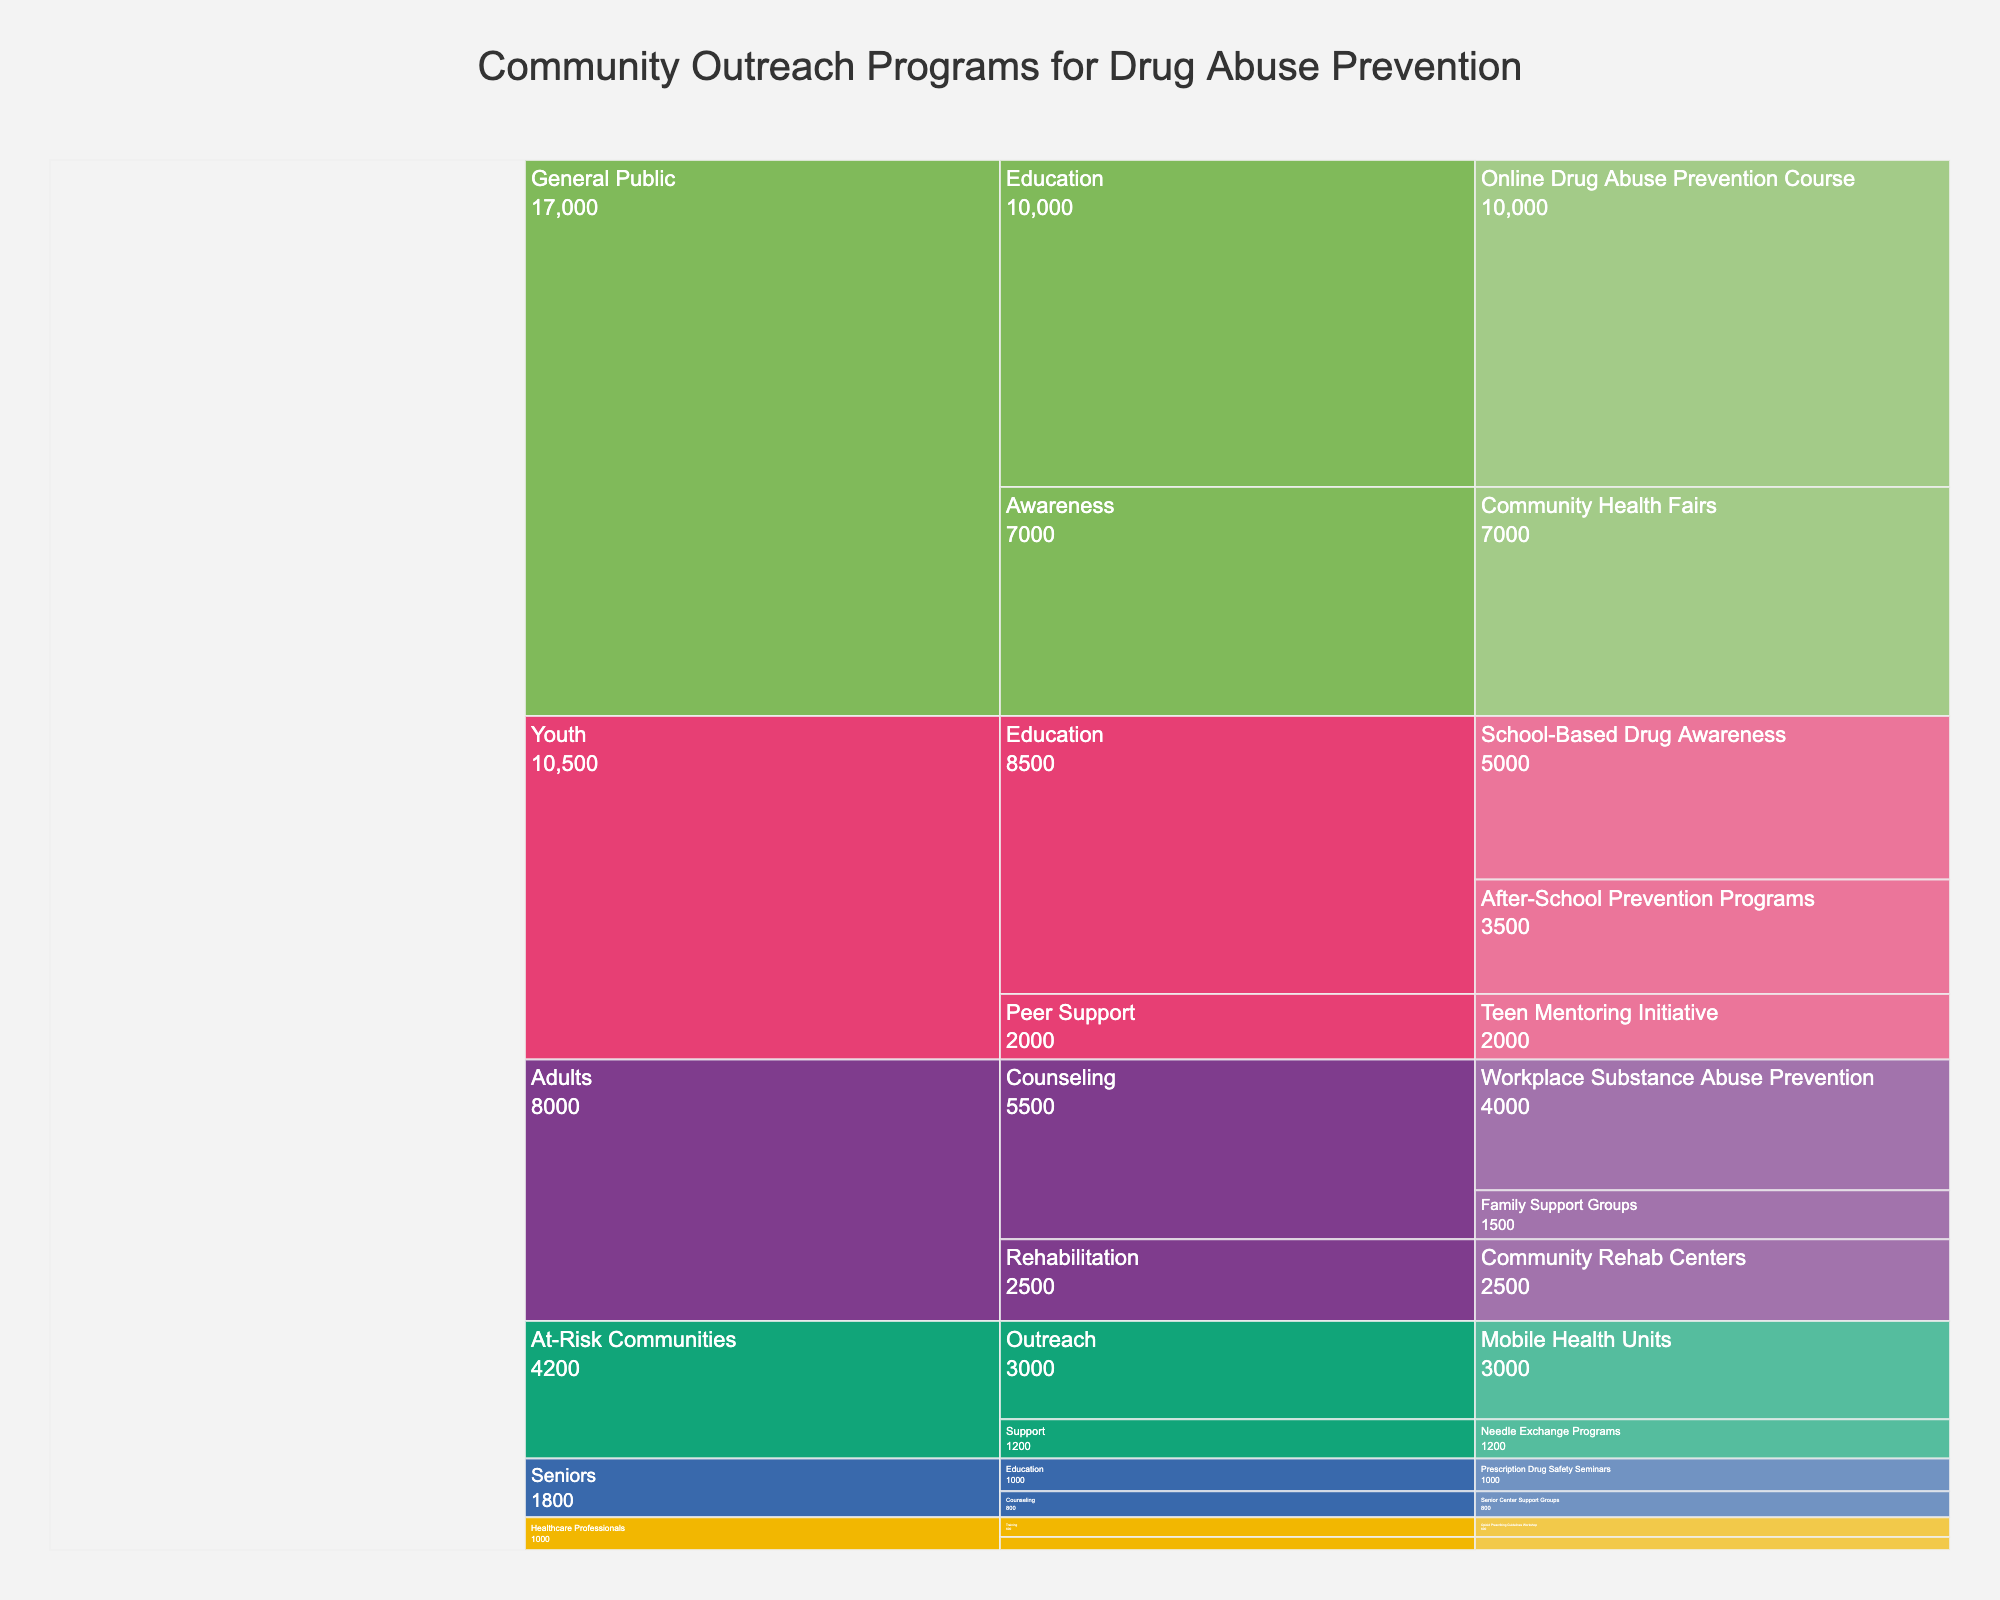What is the total number of participants in 'School-Based Drug Awareness' and 'After-School Prevention Programs'? To find the total number of participants, sum the participants in 'School-Based Drug Awareness' (5000) and 'After-School Prevention Programs' (3500). Therefore, the total is 5000 + 3500.
Answer: 8500 Which program has the highest number of participants? To determine this, look at all the programs and their participant numbers. The 'Online Drug Abuse Prevention Course' has the highest number of participants with 10,000.
Answer: Online Drug Abuse Prevention Course How many participants are involved in Education interventions for the Youth target audience? Sum the participants in 'School-Based Drug Awareness' (5000) and 'After-School Prevention Programs' (3500). Therefore, the total is 5000 + 3500.
Answer: 8500 Among the intervention methods for Adults, which one has the fewest participants? Compare the number of participants for each intervention method for Adults: Counseling (5500), Rehabilitation (2500). The fewest number of participants is for Rehabilitation with 2500 participants.
Answer: Rehabilitation What is the total number of participants for programs targeted at Healthcare Professionals? Sum the participants in 'Opioid Prescribing Guidelines Workshop' (600) and 'Substance Abuse Screening Certification' (400). Therefore, the total is 600 + 400.
Answer: 1000 Which target audience has the highest number of participants across all programs? By summing the participants in programs for each target audience and comparing, 'General Public' has the highest number of participants: 'Community Health Fairs' (7000) + 'Online Drug Abuse Prevention Course' (10000) = 17000.
Answer: General Public Which intervention method has the most participants for At-Risk Communities? Compare the number of participants for 'Mobile Health Units' (3000) and 'Needle Exchange Programs' (1200). The most participants are in 'Mobile Health Units' with 3000.
Answer: Mobile Health Units Between 'Teen Mentoring Initiative' and 'Family Support Groups', which has more participants? Compare the number of participants in 'Teen Mentoring Initiative' (2000) and 'Family Support Groups' (1500). 'Teen Mentoring Initiative' has more participants.
Answer: Teen Mentoring Initiative What is the total number of participants across all programs? Sum all the participants in each program: 5000 + 3500 + 2000 + 4000 + 1500 + 2500 + 1000 + 800 + 600 + 400 + 3000 + 1200 + 7000 + 10000. The total is 43900.
Answer: 43900 How do the total participants in Education interventions compare to Counseling interventions? Sum the participants in all Education interventions: 5000 + 3500 + 1000 + 400 + 10000 = 19900. Sum the participants in all Counseling interventions: 4000 + 1500 + 800 = 6300. Compare the two totals: 19900 (Education) vs. 6300 (Counseling). Education has more participants.
Answer: Education has more participants 